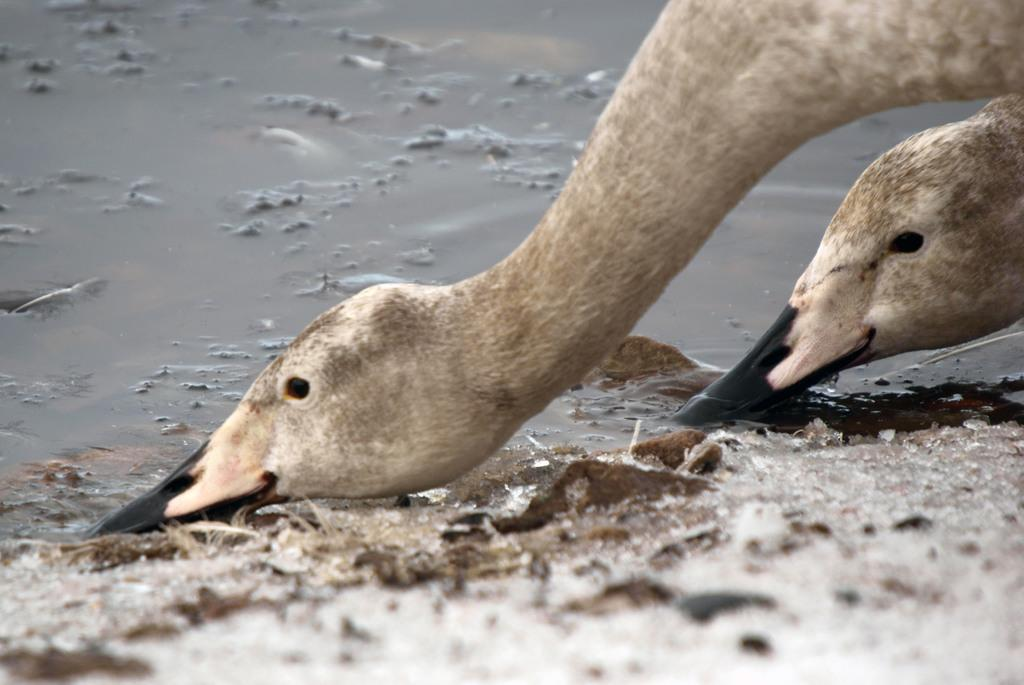What animals can be seen in the image? There are two ducks in the image. What is the primary element in which the ducks are situated? land, water, or air? What type of reward can be seen hanging from the ducks' necks in the image? There is no reward visible in the image; it features two ducks in water. 